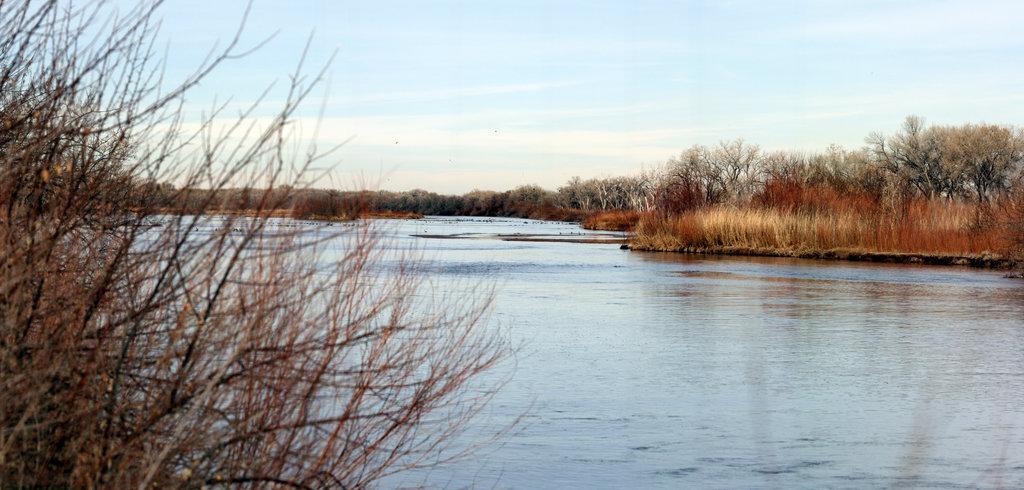How would you summarize this image in a sentence or two? In this image in the center there is one lake and also there are some plants in the foreground, and in the background there are some trees and at the top of the image there is sky. 